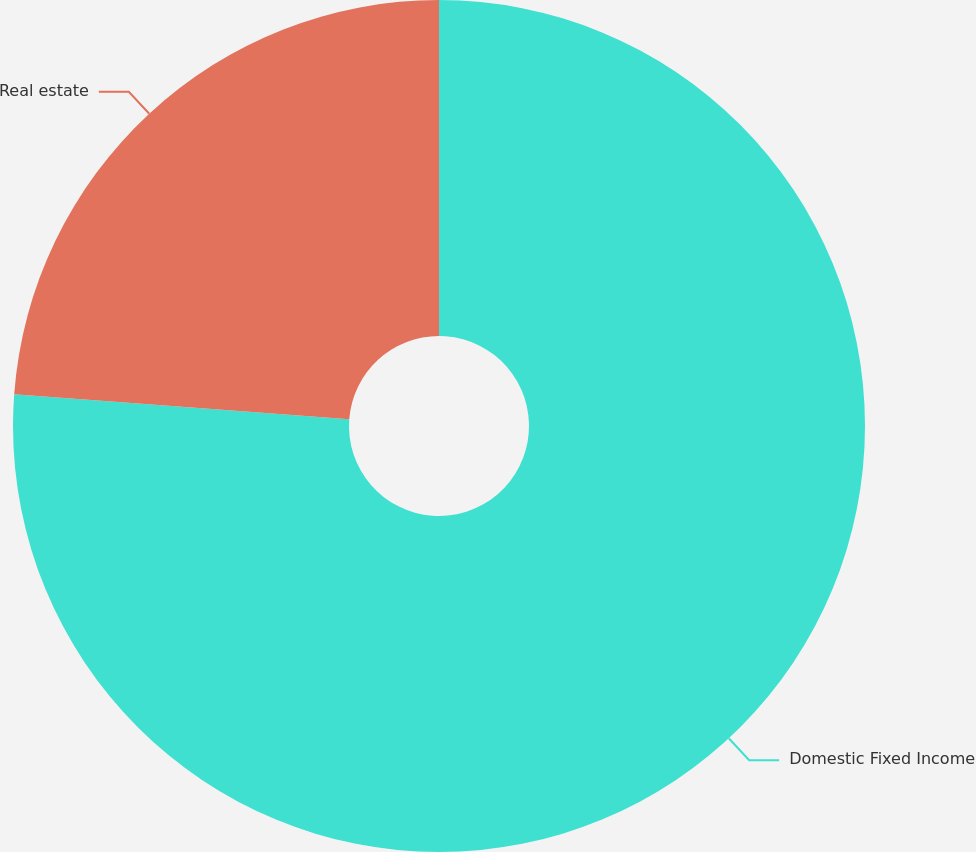Convert chart to OTSL. <chart><loc_0><loc_0><loc_500><loc_500><pie_chart><fcel>Domestic Fixed Income<fcel>Real estate<nl><fcel>76.19%<fcel>23.81%<nl></chart> 